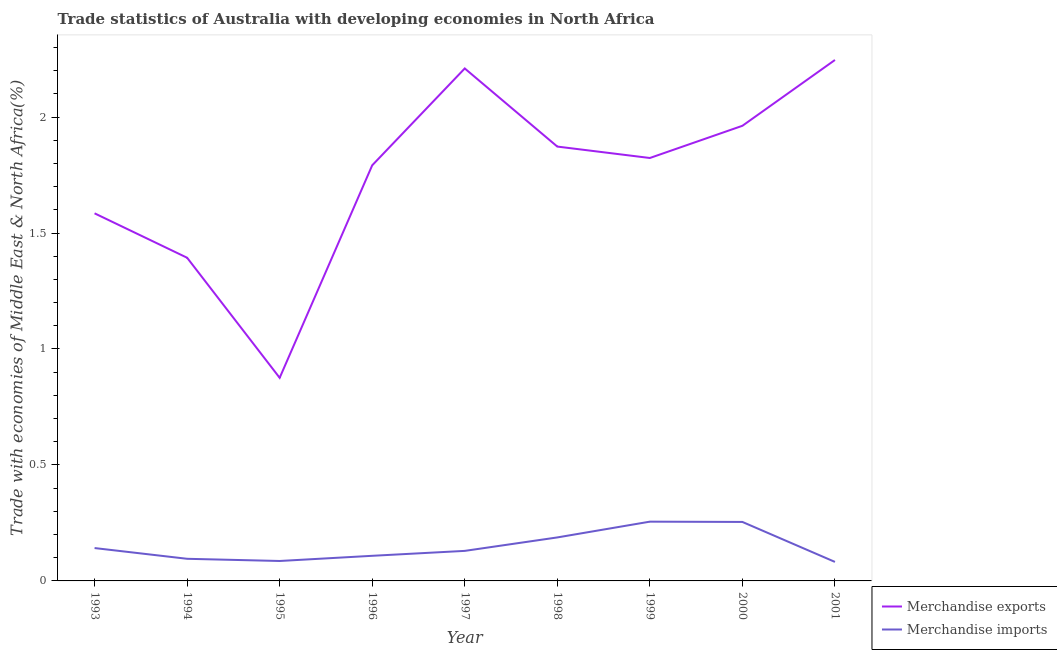How many different coloured lines are there?
Give a very brief answer. 2. Does the line corresponding to merchandise imports intersect with the line corresponding to merchandise exports?
Your answer should be compact. No. What is the merchandise exports in 1996?
Your response must be concise. 1.79. Across all years, what is the maximum merchandise exports?
Your answer should be very brief. 2.25. Across all years, what is the minimum merchandise exports?
Your response must be concise. 0.88. In which year was the merchandise exports maximum?
Your answer should be very brief. 2001. In which year was the merchandise imports minimum?
Provide a succinct answer. 2001. What is the total merchandise imports in the graph?
Give a very brief answer. 1.34. What is the difference between the merchandise exports in 1995 and that in 1996?
Provide a succinct answer. -0.92. What is the difference between the merchandise exports in 1993 and the merchandise imports in 1994?
Offer a terse response. 1.49. What is the average merchandise exports per year?
Your answer should be compact. 1.75. In the year 1996, what is the difference between the merchandise imports and merchandise exports?
Your answer should be very brief. -1.68. What is the ratio of the merchandise exports in 1997 to that in 2001?
Provide a succinct answer. 0.98. Is the difference between the merchandise imports in 1993 and 2000 greater than the difference between the merchandise exports in 1993 and 2000?
Keep it short and to the point. Yes. What is the difference between the highest and the second highest merchandise imports?
Ensure brevity in your answer.  0. What is the difference between the highest and the lowest merchandise imports?
Give a very brief answer. 0.17. In how many years, is the merchandise imports greater than the average merchandise imports taken over all years?
Your response must be concise. 3. Does the merchandise imports monotonically increase over the years?
Your response must be concise. No. Is the merchandise imports strictly less than the merchandise exports over the years?
Ensure brevity in your answer.  Yes. What is the difference between two consecutive major ticks on the Y-axis?
Offer a very short reply. 0.5. Are the values on the major ticks of Y-axis written in scientific E-notation?
Keep it short and to the point. No. Does the graph contain any zero values?
Provide a short and direct response. No. Where does the legend appear in the graph?
Give a very brief answer. Bottom right. How many legend labels are there?
Your answer should be compact. 2. How are the legend labels stacked?
Your answer should be very brief. Vertical. What is the title of the graph?
Make the answer very short. Trade statistics of Australia with developing economies in North Africa. What is the label or title of the Y-axis?
Your answer should be very brief. Trade with economies of Middle East & North Africa(%). What is the Trade with economies of Middle East & North Africa(%) of Merchandise exports in 1993?
Provide a succinct answer. 1.58. What is the Trade with economies of Middle East & North Africa(%) of Merchandise imports in 1993?
Offer a terse response. 0.14. What is the Trade with economies of Middle East & North Africa(%) of Merchandise exports in 1994?
Offer a terse response. 1.39. What is the Trade with economies of Middle East & North Africa(%) in Merchandise imports in 1994?
Offer a terse response. 0.1. What is the Trade with economies of Middle East & North Africa(%) of Merchandise exports in 1995?
Ensure brevity in your answer.  0.88. What is the Trade with economies of Middle East & North Africa(%) in Merchandise imports in 1995?
Offer a very short reply. 0.09. What is the Trade with economies of Middle East & North Africa(%) in Merchandise exports in 1996?
Your response must be concise. 1.79. What is the Trade with economies of Middle East & North Africa(%) of Merchandise imports in 1996?
Keep it short and to the point. 0.11. What is the Trade with economies of Middle East & North Africa(%) of Merchandise exports in 1997?
Offer a very short reply. 2.21. What is the Trade with economies of Middle East & North Africa(%) of Merchandise imports in 1997?
Provide a succinct answer. 0.13. What is the Trade with economies of Middle East & North Africa(%) in Merchandise exports in 1998?
Your answer should be very brief. 1.87. What is the Trade with economies of Middle East & North Africa(%) in Merchandise imports in 1998?
Keep it short and to the point. 0.19. What is the Trade with economies of Middle East & North Africa(%) in Merchandise exports in 1999?
Your answer should be compact. 1.82. What is the Trade with economies of Middle East & North Africa(%) of Merchandise imports in 1999?
Give a very brief answer. 0.26. What is the Trade with economies of Middle East & North Africa(%) of Merchandise exports in 2000?
Ensure brevity in your answer.  1.96. What is the Trade with economies of Middle East & North Africa(%) of Merchandise imports in 2000?
Your response must be concise. 0.25. What is the Trade with economies of Middle East & North Africa(%) of Merchandise exports in 2001?
Provide a short and direct response. 2.25. What is the Trade with economies of Middle East & North Africa(%) of Merchandise imports in 2001?
Your answer should be compact. 0.08. Across all years, what is the maximum Trade with economies of Middle East & North Africa(%) in Merchandise exports?
Keep it short and to the point. 2.25. Across all years, what is the maximum Trade with economies of Middle East & North Africa(%) in Merchandise imports?
Offer a terse response. 0.26. Across all years, what is the minimum Trade with economies of Middle East & North Africa(%) in Merchandise exports?
Your answer should be compact. 0.88. Across all years, what is the minimum Trade with economies of Middle East & North Africa(%) in Merchandise imports?
Your answer should be very brief. 0.08. What is the total Trade with economies of Middle East & North Africa(%) of Merchandise exports in the graph?
Offer a very short reply. 15.76. What is the total Trade with economies of Middle East & North Africa(%) in Merchandise imports in the graph?
Offer a terse response. 1.34. What is the difference between the Trade with economies of Middle East & North Africa(%) of Merchandise exports in 1993 and that in 1994?
Provide a short and direct response. 0.19. What is the difference between the Trade with economies of Middle East & North Africa(%) of Merchandise imports in 1993 and that in 1994?
Provide a succinct answer. 0.05. What is the difference between the Trade with economies of Middle East & North Africa(%) in Merchandise exports in 1993 and that in 1995?
Your response must be concise. 0.71. What is the difference between the Trade with economies of Middle East & North Africa(%) of Merchandise imports in 1993 and that in 1995?
Your answer should be compact. 0.06. What is the difference between the Trade with economies of Middle East & North Africa(%) in Merchandise exports in 1993 and that in 1996?
Provide a succinct answer. -0.21. What is the difference between the Trade with economies of Middle East & North Africa(%) of Merchandise imports in 1993 and that in 1996?
Give a very brief answer. 0.03. What is the difference between the Trade with economies of Middle East & North Africa(%) of Merchandise exports in 1993 and that in 1997?
Offer a terse response. -0.62. What is the difference between the Trade with economies of Middle East & North Africa(%) in Merchandise imports in 1993 and that in 1997?
Provide a succinct answer. 0.01. What is the difference between the Trade with economies of Middle East & North Africa(%) of Merchandise exports in 1993 and that in 1998?
Ensure brevity in your answer.  -0.29. What is the difference between the Trade with economies of Middle East & North Africa(%) of Merchandise imports in 1993 and that in 1998?
Your response must be concise. -0.05. What is the difference between the Trade with economies of Middle East & North Africa(%) of Merchandise exports in 1993 and that in 1999?
Your response must be concise. -0.24. What is the difference between the Trade with economies of Middle East & North Africa(%) in Merchandise imports in 1993 and that in 1999?
Offer a very short reply. -0.11. What is the difference between the Trade with economies of Middle East & North Africa(%) of Merchandise exports in 1993 and that in 2000?
Offer a terse response. -0.38. What is the difference between the Trade with economies of Middle East & North Africa(%) of Merchandise imports in 1993 and that in 2000?
Give a very brief answer. -0.11. What is the difference between the Trade with economies of Middle East & North Africa(%) in Merchandise exports in 1993 and that in 2001?
Make the answer very short. -0.66. What is the difference between the Trade with economies of Middle East & North Africa(%) in Merchandise imports in 1993 and that in 2001?
Ensure brevity in your answer.  0.06. What is the difference between the Trade with economies of Middle East & North Africa(%) in Merchandise exports in 1994 and that in 1995?
Keep it short and to the point. 0.52. What is the difference between the Trade with economies of Middle East & North Africa(%) in Merchandise imports in 1994 and that in 1995?
Provide a succinct answer. 0.01. What is the difference between the Trade with economies of Middle East & North Africa(%) in Merchandise exports in 1994 and that in 1996?
Offer a very short reply. -0.4. What is the difference between the Trade with economies of Middle East & North Africa(%) in Merchandise imports in 1994 and that in 1996?
Your answer should be very brief. -0.01. What is the difference between the Trade with economies of Middle East & North Africa(%) of Merchandise exports in 1994 and that in 1997?
Make the answer very short. -0.82. What is the difference between the Trade with economies of Middle East & North Africa(%) in Merchandise imports in 1994 and that in 1997?
Provide a short and direct response. -0.03. What is the difference between the Trade with economies of Middle East & North Africa(%) in Merchandise exports in 1994 and that in 1998?
Your answer should be very brief. -0.48. What is the difference between the Trade with economies of Middle East & North Africa(%) of Merchandise imports in 1994 and that in 1998?
Your answer should be compact. -0.09. What is the difference between the Trade with economies of Middle East & North Africa(%) of Merchandise exports in 1994 and that in 1999?
Your answer should be very brief. -0.43. What is the difference between the Trade with economies of Middle East & North Africa(%) of Merchandise imports in 1994 and that in 1999?
Your response must be concise. -0.16. What is the difference between the Trade with economies of Middle East & North Africa(%) in Merchandise exports in 1994 and that in 2000?
Offer a very short reply. -0.57. What is the difference between the Trade with economies of Middle East & North Africa(%) in Merchandise imports in 1994 and that in 2000?
Make the answer very short. -0.16. What is the difference between the Trade with economies of Middle East & North Africa(%) of Merchandise exports in 1994 and that in 2001?
Offer a very short reply. -0.85. What is the difference between the Trade with economies of Middle East & North Africa(%) in Merchandise imports in 1994 and that in 2001?
Offer a very short reply. 0.01. What is the difference between the Trade with economies of Middle East & North Africa(%) of Merchandise exports in 1995 and that in 1996?
Ensure brevity in your answer.  -0.92. What is the difference between the Trade with economies of Middle East & North Africa(%) of Merchandise imports in 1995 and that in 1996?
Offer a very short reply. -0.02. What is the difference between the Trade with economies of Middle East & North Africa(%) in Merchandise exports in 1995 and that in 1997?
Keep it short and to the point. -1.33. What is the difference between the Trade with economies of Middle East & North Africa(%) of Merchandise imports in 1995 and that in 1997?
Ensure brevity in your answer.  -0.04. What is the difference between the Trade with economies of Middle East & North Africa(%) in Merchandise exports in 1995 and that in 1998?
Provide a succinct answer. -1. What is the difference between the Trade with economies of Middle East & North Africa(%) of Merchandise imports in 1995 and that in 1998?
Your response must be concise. -0.1. What is the difference between the Trade with economies of Middle East & North Africa(%) in Merchandise exports in 1995 and that in 1999?
Offer a terse response. -0.95. What is the difference between the Trade with economies of Middle East & North Africa(%) in Merchandise imports in 1995 and that in 1999?
Ensure brevity in your answer.  -0.17. What is the difference between the Trade with economies of Middle East & North Africa(%) of Merchandise exports in 1995 and that in 2000?
Make the answer very short. -1.09. What is the difference between the Trade with economies of Middle East & North Africa(%) of Merchandise imports in 1995 and that in 2000?
Make the answer very short. -0.17. What is the difference between the Trade with economies of Middle East & North Africa(%) in Merchandise exports in 1995 and that in 2001?
Ensure brevity in your answer.  -1.37. What is the difference between the Trade with economies of Middle East & North Africa(%) of Merchandise imports in 1995 and that in 2001?
Provide a succinct answer. 0. What is the difference between the Trade with economies of Middle East & North Africa(%) in Merchandise exports in 1996 and that in 1997?
Your response must be concise. -0.42. What is the difference between the Trade with economies of Middle East & North Africa(%) in Merchandise imports in 1996 and that in 1997?
Ensure brevity in your answer.  -0.02. What is the difference between the Trade with economies of Middle East & North Africa(%) of Merchandise exports in 1996 and that in 1998?
Keep it short and to the point. -0.08. What is the difference between the Trade with economies of Middle East & North Africa(%) of Merchandise imports in 1996 and that in 1998?
Make the answer very short. -0.08. What is the difference between the Trade with economies of Middle East & North Africa(%) in Merchandise exports in 1996 and that in 1999?
Your answer should be compact. -0.03. What is the difference between the Trade with economies of Middle East & North Africa(%) of Merchandise imports in 1996 and that in 1999?
Offer a terse response. -0.15. What is the difference between the Trade with economies of Middle East & North Africa(%) in Merchandise exports in 1996 and that in 2000?
Keep it short and to the point. -0.17. What is the difference between the Trade with economies of Middle East & North Africa(%) of Merchandise imports in 1996 and that in 2000?
Your answer should be very brief. -0.15. What is the difference between the Trade with economies of Middle East & North Africa(%) of Merchandise exports in 1996 and that in 2001?
Offer a terse response. -0.45. What is the difference between the Trade with economies of Middle East & North Africa(%) of Merchandise imports in 1996 and that in 2001?
Provide a short and direct response. 0.03. What is the difference between the Trade with economies of Middle East & North Africa(%) of Merchandise exports in 1997 and that in 1998?
Offer a very short reply. 0.34. What is the difference between the Trade with economies of Middle East & North Africa(%) of Merchandise imports in 1997 and that in 1998?
Offer a very short reply. -0.06. What is the difference between the Trade with economies of Middle East & North Africa(%) of Merchandise exports in 1997 and that in 1999?
Keep it short and to the point. 0.39. What is the difference between the Trade with economies of Middle East & North Africa(%) in Merchandise imports in 1997 and that in 1999?
Give a very brief answer. -0.13. What is the difference between the Trade with economies of Middle East & North Africa(%) in Merchandise exports in 1997 and that in 2000?
Offer a terse response. 0.25. What is the difference between the Trade with economies of Middle East & North Africa(%) in Merchandise imports in 1997 and that in 2000?
Offer a terse response. -0.12. What is the difference between the Trade with economies of Middle East & North Africa(%) in Merchandise exports in 1997 and that in 2001?
Your answer should be compact. -0.04. What is the difference between the Trade with economies of Middle East & North Africa(%) of Merchandise imports in 1997 and that in 2001?
Provide a short and direct response. 0.05. What is the difference between the Trade with economies of Middle East & North Africa(%) of Merchandise exports in 1998 and that in 1999?
Keep it short and to the point. 0.05. What is the difference between the Trade with economies of Middle East & North Africa(%) in Merchandise imports in 1998 and that in 1999?
Your response must be concise. -0.07. What is the difference between the Trade with economies of Middle East & North Africa(%) in Merchandise exports in 1998 and that in 2000?
Provide a short and direct response. -0.09. What is the difference between the Trade with economies of Middle East & North Africa(%) in Merchandise imports in 1998 and that in 2000?
Ensure brevity in your answer.  -0.07. What is the difference between the Trade with economies of Middle East & North Africa(%) in Merchandise exports in 1998 and that in 2001?
Provide a succinct answer. -0.37. What is the difference between the Trade with economies of Middle East & North Africa(%) in Merchandise imports in 1998 and that in 2001?
Make the answer very short. 0.11. What is the difference between the Trade with economies of Middle East & North Africa(%) in Merchandise exports in 1999 and that in 2000?
Your answer should be very brief. -0.14. What is the difference between the Trade with economies of Middle East & North Africa(%) in Merchandise imports in 1999 and that in 2000?
Your answer should be very brief. 0. What is the difference between the Trade with economies of Middle East & North Africa(%) in Merchandise exports in 1999 and that in 2001?
Keep it short and to the point. -0.42. What is the difference between the Trade with economies of Middle East & North Africa(%) of Merchandise imports in 1999 and that in 2001?
Give a very brief answer. 0.17. What is the difference between the Trade with economies of Middle East & North Africa(%) of Merchandise exports in 2000 and that in 2001?
Your answer should be very brief. -0.28. What is the difference between the Trade with economies of Middle East & North Africa(%) in Merchandise imports in 2000 and that in 2001?
Give a very brief answer. 0.17. What is the difference between the Trade with economies of Middle East & North Africa(%) in Merchandise exports in 1993 and the Trade with economies of Middle East & North Africa(%) in Merchandise imports in 1994?
Provide a short and direct response. 1.49. What is the difference between the Trade with economies of Middle East & North Africa(%) of Merchandise exports in 1993 and the Trade with economies of Middle East & North Africa(%) of Merchandise imports in 1995?
Offer a terse response. 1.5. What is the difference between the Trade with economies of Middle East & North Africa(%) of Merchandise exports in 1993 and the Trade with economies of Middle East & North Africa(%) of Merchandise imports in 1996?
Your response must be concise. 1.48. What is the difference between the Trade with economies of Middle East & North Africa(%) in Merchandise exports in 1993 and the Trade with economies of Middle East & North Africa(%) in Merchandise imports in 1997?
Give a very brief answer. 1.46. What is the difference between the Trade with economies of Middle East & North Africa(%) in Merchandise exports in 1993 and the Trade with economies of Middle East & North Africa(%) in Merchandise imports in 1998?
Ensure brevity in your answer.  1.4. What is the difference between the Trade with economies of Middle East & North Africa(%) of Merchandise exports in 1993 and the Trade with economies of Middle East & North Africa(%) of Merchandise imports in 1999?
Provide a short and direct response. 1.33. What is the difference between the Trade with economies of Middle East & North Africa(%) of Merchandise exports in 1993 and the Trade with economies of Middle East & North Africa(%) of Merchandise imports in 2000?
Give a very brief answer. 1.33. What is the difference between the Trade with economies of Middle East & North Africa(%) of Merchandise exports in 1993 and the Trade with economies of Middle East & North Africa(%) of Merchandise imports in 2001?
Ensure brevity in your answer.  1.5. What is the difference between the Trade with economies of Middle East & North Africa(%) of Merchandise exports in 1994 and the Trade with economies of Middle East & North Africa(%) of Merchandise imports in 1995?
Your answer should be very brief. 1.31. What is the difference between the Trade with economies of Middle East & North Africa(%) in Merchandise exports in 1994 and the Trade with economies of Middle East & North Africa(%) in Merchandise imports in 1996?
Keep it short and to the point. 1.29. What is the difference between the Trade with economies of Middle East & North Africa(%) in Merchandise exports in 1994 and the Trade with economies of Middle East & North Africa(%) in Merchandise imports in 1997?
Your response must be concise. 1.26. What is the difference between the Trade with economies of Middle East & North Africa(%) in Merchandise exports in 1994 and the Trade with economies of Middle East & North Africa(%) in Merchandise imports in 1998?
Your response must be concise. 1.21. What is the difference between the Trade with economies of Middle East & North Africa(%) in Merchandise exports in 1994 and the Trade with economies of Middle East & North Africa(%) in Merchandise imports in 1999?
Offer a very short reply. 1.14. What is the difference between the Trade with economies of Middle East & North Africa(%) of Merchandise exports in 1994 and the Trade with economies of Middle East & North Africa(%) of Merchandise imports in 2000?
Keep it short and to the point. 1.14. What is the difference between the Trade with economies of Middle East & North Africa(%) of Merchandise exports in 1994 and the Trade with economies of Middle East & North Africa(%) of Merchandise imports in 2001?
Make the answer very short. 1.31. What is the difference between the Trade with economies of Middle East & North Africa(%) in Merchandise exports in 1995 and the Trade with economies of Middle East & North Africa(%) in Merchandise imports in 1996?
Your response must be concise. 0.77. What is the difference between the Trade with economies of Middle East & North Africa(%) of Merchandise exports in 1995 and the Trade with economies of Middle East & North Africa(%) of Merchandise imports in 1997?
Ensure brevity in your answer.  0.75. What is the difference between the Trade with economies of Middle East & North Africa(%) in Merchandise exports in 1995 and the Trade with economies of Middle East & North Africa(%) in Merchandise imports in 1998?
Offer a terse response. 0.69. What is the difference between the Trade with economies of Middle East & North Africa(%) in Merchandise exports in 1995 and the Trade with economies of Middle East & North Africa(%) in Merchandise imports in 1999?
Ensure brevity in your answer.  0.62. What is the difference between the Trade with economies of Middle East & North Africa(%) in Merchandise exports in 1995 and the Trade with economies of Middle East & North Africa(%) in Merchandise imports in 2000?
Offer a terse response. 0.62. What is the difference between the Trade with economies of Middle East & North Africa(%) in Merchandise exports in 1995 and the Trade with economies of Middle East & North Africa(%) in Merchandise imports in 2001?
Ensure brevity in your answer.  0.79. What is the difference between the Trade with economies of Middle East & North Africa(%) of Merchandise exports in 1996 and the Trade with economies of Middle East & North Africa(%) of Merchandise imports in 1997?
Provide a short and direct response. 1.66. What is the difference between the Trade with economies of Middle East & North Africa(%) of Merchandise exports in 1996 and the Trade with economies of Middle East & North Africa(%) of Merchandise imports in 1998?
Ensure brevity in your answer.  1.6. What is the difference between the Trade with economies of Middle East & North Africa(%) in Merchandise exports in 1996 and the Trade with economies of Middle East & North Africa(%) in Merchandise imports in 1999?
Your response must be concise. 1.54. What is the difference between the Trade with economies of Middle East & North Africa(%) in Merchandise exports in 1996 and the Trade with economies of Middle East & North Africa(%) in Merchandise imports in 2000?
Your answer should be compact. 1.54. What is the difference between the Trade with economies of Middle East & North Africa(%) of Merchandise exports in 1996 and the Trade with economies of Middle East & North Africa(%) of Merchandise imports in 2001?
Ensure brevity in your answer.  1.71. What is the difference between the Trade with economies of Middle East & North Africa(%) in Merchandise exports in 1997 and the Trade with economies of Middle East & North Africa(%) in Merchandise imports in 1998?
Offer a terse response. 2.02. What is the difference between the Trade with economies of Middle East & North Africa(%) of Merchandise exports in 1997 and the Trade with economies of Middle East & North Africa(%) of Merchandise imports in 1999?
Provide a short and direct response. 1.95. What is the difference between the Trade with economies of Middle East & North Africa(%) in Merchandise exports in 1997 and the Trade with economies of Middle East & North Africa(%) in Merchandise imports in 2000?
Ensure brevity in your answer.  1.96. What is the difference between the Trade with economies of Middle East & North Africa(%) of Merchandise exports in 1997 and the Trade with economies of Middle East & North Africa(%) of Merchandise imports in 2001?
Offer a terse response. 2.13. What is the difference between the Trade with economies of Middle East & North Africa(%) of Merchandise exports in 1998 and the Trade with economies of Middle East & North Africa(%) of Merchandise imports in 1999?
Provide a short and direct response. 1.62. What is the difference between the Trade with economies of Middle East & North Africa(%) in Merchandise exports in 1998 and the Trade with economies of Middle East & North Africa(%) in Merchandise imports in 2000?
Your answer should be very brief. 1.62. What is the difference between the Trade with economies of Middle East & North Africa(%) of Merchandise exports in 1998 and the Trade with economies of Middle East & North Africa(%) of Merchandise imports in 2001?
Your response must be concise. 1.79. What is the difference between the Trade with economies of Middle East & North Africa(%) of Merchandise exports in 1999 and the Trade with economies of Middle East & North Africa(%) of Merchandise imports in 2000?
Your answer should be very brief. 1.57. What is the difference between the Trade with economies of Middle East & North Africa(%) in Merchandise exports in 1999 and the Trade with economies of Middle East & North Africa(%) in Merchandise imports in 2001?
Provide a short and direct response. 1.74. What is the difference between the Trade with economies of Middle East & North Africa(%) of Merchandise exports in 2000 and the Trade with economies of Middle East & North Africa(%) of Merchandise imports in 2001?
Your answer should be very brief. 1.88. What is the average Trade with economies of Middle East & North Africa(%) in Merchandise exports per year?
Make the answer very short. 1.75. What is the average Trade with economies of Middle East & North Africa(%) of Merchandise imports per year?
Provide a succinct answer. 0.15. In the year 1993, what is the difference between the Trade with economies of Middle East & North Africa(%) in Merchandise exports and Trade with economies of Middle East & North Africa(%) in Merchandise imports?
Your response must be concise. 1.44. In the year 1994, what is the difference between the Trade with economies of Middle East & North Africa(%) of Merchandise exports and Trade with economies of Middle East & North Africa(%) of Merchandise imports?
Provide a short and direct response. 1.3. In the year 1995, what is the difference between the Trade with economies of Middle East & North Africa(%) of Merchandise exports and Trade with economies of Middle East & North Africa(%) of Merchandise imports?
Make the answer very short. 0.79. In the year 1996, what is the difference between the Trade with economies of Middle East & North Africa(%) of Merchandise exports and Trade with economies of Middle East & North Africa(%) of Merchandise imports?
Keep it short and to the point. 1.68. In the year 1997, what is the difference between the Trade with economies of Middle East & North Africa(%) of Merchandise exports and Trade with economies of Middle East & North Africa(%) of Merchandise imports?
Ensure brevity in your answer.  2.08. In the year 1998, what is the difference between the Trade with economies of Middle East & North Africa(%) of Merchandise exports and Trade with economies of Middle East & North Africa(%) of Merchandise imports?
Your answer should be very brief. 1.69. In the year 1999, what is the difference between the Trade with economies of Middle East & North Africa(%) in Merchandise exports and Trade with economies of Middle East & North Africa(%) in Merchandise imports?
Provide a succinct answer. 1.57. In the year 2000, what is the difference between the Trade with economies of Middle East & North Africa(%) of Merchandise exports and Trade with economies of Middle East & North Africa(%) of Merchandise imports?
Your response must be concise. 1.71. In the year 2001, what is the difference between the Trade with economies of Middle East & North Africa(%) of Merchandise exports and Trade with economies of Middle East & North Africa(%) of Merchandise imports?
Keep it short and to the point. 2.16. What is the ratio of the Trade with economies of Middle East & North Africa(%) in Merchandise exports in 1993 to that in 1994?
Provide a short and direct response. 1.14. What is the ratio of the Trade with economies of Middle East & North Africa(%) of Merchandise imports in 1993 to that in 1994?
Your answer should be very brief. 1.49. What is the ratio of the Trade with economies of Middle East & North Africa(%) of Merchandise exports in 1993 to that in 1995?
Provide a short and direct response. 1.81. What is the ratio of the Trade with economies of Middle East & North Africa(%) of Merchandise imports in 1993 to that in 1995?
Offer a very short reply. 1.65. What is the ratio of the Trade with economies of Middle East & North Africa(%) in Merchandise exports in 1993 to that in 1996?
Offer a terse response. 0.88. What is the ratio of the Trade with economies of Middle East & North Africa(%) in Merchandise imports in 1993 to that in 1996?
Your response must be concise. 1.31. What is the ratio of the Trade with economies of Middle East & North Africa(%) in Merchandise exports in 1993 to that in 1997?
Keep it short and to the point. 0.72. What is the ratio of the Trade with economies of Middle East & North Africa(%) in Merchandise imports in 1993 to that in 1997?
Your response must be concise. 1.09. What is the ratio of the Trade with economies of Middle East & North Africa(%) in Merchandise exports in 1993 to that in 1998?
Your answer should be compact. 0.85. What is the ratio of the Trade with economies of Middle East & North Africa(%) in Merchandise imports in 1993 to that in 1998?
Provide a succinct answer. 0.76. What is the ratio of the Trade with economies of Middle East & North Africa(%) in Merchandise exports in 1993 to that in 1999?
Provide a succinct answer. 0.87. What is the ratio of the Trade with economies of Middle East & North Africa(%) of Merchandise imports in 1993 to that in 1999?
Ensure brevity in your answer.  0.55. What is the ratio of the Trade with economies of Middle East & North Africa(%) of Merchandise exports in 1993 to that in 2000?
Ensure brevity in your answer.  0.81. What is the ratio of the Trade with economies of Middle East & North Africa(%) in Merchandise imports in 1993 to that in 2000?
Provide a short and direct response. 0.56. What is the ratio of the Trade with economies of Middle East & North Africa(%) in Merchandise exports in 1993 to that in 2001?
Provide a short and direct response. 0.71. What is the ratio of the Trade with economies of Middle East & North Africa(%) in Merchandise imports in 1993 to that in 2001?
Ensure brevity in your answer.  1.73. What is the ratio of the Trade with economies of Middle East & North Africa(%) in Merchandise exports in 1994 to that in 1995?
Ensure brevity in your answer.  1.59. What is the ratio of the Trade with economies of Middle East & North Africa(%) of Merchandise imports in 1994 to that in 1995?
Your answer should be very brief. 1.11. What is the ratio of the Trade with economies of Middle East & North Africa(%) of Merchandise exports in 1994 to that in 1996?
Provide a short and direct response. 0.78. What is the ratio of the Trade with economies of Middle East & North Africa(%) of Merchandise imports in 1994 to that in 1996?
Keep it short and to the point. 0.88. What is the ratio of the Trade with economies of Middle East & North Africa(%) of Merchandise exports in 1994 to that in 1997?
Your answer should be very brief. 0.63. What is the ratio of the Trade with economies of Middle East & North Africa(%) in Merchandise imports in 1994 to that in 1997?
Offer a very short reply. 0.74. What is the ratio of the Trade with economies of Middle East & North Africa(%) in Merchandise exports in 1994 to that in 1998?
Keep it short and to the point. 0.74. What is the ratio of the Trade with economies of Middle East & North Africa(%) of Merchandise imports in 1994 to that in 1998?
Give a very brief answer. 0.51. What is the ratio of the Trade with economies of Middle East & North Africa(%) of Merchandise exports in 1994 to that in 1999?
Provide a short and direct response. 0.76. What is the ratio of the Trade with economies of Middle East & North Africa(%) of Merchandise imports in 1994 to that in 1999?
Offer a terse response. 0.37. What is the ratio of the Trade with economies of Middle East & North Africa(%) of Merchandise exports in 1994 to that in 2000?
Make the answer very short. 0.71. What is the ratio of the Trade with economies of Middle East & North Africa(%) of Merchandise imports in 1994 to that in 2000?
Provide a succinct answer. 0.38. What is the ratio of the Trade with economies of Middle East & North Africa(%) of Merchandise exports in 1994 to that in 2001?
Your answer should be very brief. 0.62. What is the ratio of the Trade with economies of Middle East & North Africa(%) in Merchandise imports in 1994 to that in 2001?
Keep it short and to the point. 1.16. What is the ratio of the Trade with economies of Middle East & North Africa(%) in Merchandise exports in 1995 to that in 1996?
Offer a terse response. 0.49. What is the ratio of the Trade with economies of Middle East & North Africa(%) of Merchandise imports in 1995 to that in 1996?
Provide a short and direct response. 0.79. What is the ratio of the Trade with economies of Middle East & North Africa(%) of Merchandise exports in 1995 to that in 1997?
Offer a terse response. 0.4. What is the ratio of the Trade with economies of Middle East & North Africa(%) of Merchandise imports in 1995 to that in 1997?
Offer a very short reply. 0.66. What is the ratio of the Trade with economies of Middle East & North Africa(%) in Merchandise exports in 1995 to that in 1998?
Keep it short and to the point. 0.47. What is the ratio of the Trade with economies of Middle East & North Africa(%) of Merchandise imports in 1995 to that in 1998?
Your response must be concise. 0.46. What is the ratio of the Trade with economies of Middle East & North Africa(%) of Merchandise exports in 1995 to that in 1999?
Your response must be concise. 0.48. What is the ratio of the Trade with economies of Middle East & North Africa(%) of Merchandise imports in 1995 to that in 1999?
Offer a very short reply. 0.34. What is the ratio of the Trade with economies of Middle East & North Africa(%) in Merchandise exports in 1995 to that in 2000?
Your answer should be compact. 0.45. What is the ratio of the Trade with economies of Middle East & North Africa(%) in Merchandise imports in 1995 to that in 2000?
Provide a succinct answer. 0.34. What is the ratio of the Trade with economies of Middle East & North Africa(%) of Merchandise exports in 1995 to that in 2001?
Make the answer very short. 0.39. What is the ratio of the Trade with economies of Middle East & North Africa(%) in Merchandise imports in 1995 to that in 2001?
Provide a short and direct response. 1.05. What is the ratio of the Trade with economies of Middle East & North Africa(%) of Merchandise exports in 1996 to that in 1997?
Your answer should be compact. 0.81. What is the ratio of the Trade with economies of Middle East & North Africa(%) of Merchandise imports in 1996 to that in 1997?
Make the answer very short. 0.84. What is the ratio of the Trade with economies of Middle East & North Africa(%) in Merchandise exports in 1996 to that in 1998?
Provide a succinct answer. 0.96. What is the ratio of the Trade with economies of Middle East & North Africa(%) of Merchandise imports in 1996 to that in 1998?
Provide a short and direct response. 0.58. What is the ratio of the Trade with economies of Middle East & North Africa(%) of Merchandise exports in 1996 to that in 1999?
Ensure brevity in your answer.  0.98. What is the ratio of the Trade with economies of Middle East & North Africa(%) in Merchandise imports in 1996 to that in 1999?
Offer a very short reply. 0.42. What is the ratio of the Trade with economies of Middle East & North Africa(%) in Merchandise exports in 1996 to that in 2000?
Offer a very short reply. 0.91. What is the ratio of the Trade with economies of Middle East & North Africa(%) of Merchandise imports in 1996 to that in 2000?
Offer a terse response. 0.43. What is the ratio of the Trade with economies of Middle East & North Africa(%) in Merchandise exports in 1996 to that in 2001?
Offer a terse response. 0.8. What is the ratio of the Trade with economies of Middle East & North Africa(%) in Merchandise imports in 1996 to that in 2001?
Ensure brevity in your answer.  1.32. What is the ratio of the Trade with economies of Middle East & North Africa(%) of Merchandise exports in 1997 to that in 1998?
Your answer should be very brief. 1.18. What is the ratio of the Trade with economies of Middle East & North Africa(%) in Merchandise imports in 1997 to that in 1998?
Offer a very short reply. 0.69. What is the ratio of the Trade with economies of Middle East & North Africa(%) of Merchandise exports in 1997 to that in 1999?
Give a very brief answer. 1.21. What is the ratio of the Trade with economies of Middle East & North Africa(%) in Merchandise imports in 1997 to that in 1999?
Provide a short and direct response. 0.51. What is the ratio of the Trade with economies of Middle East & North Africa(%) in Merchandise exports in 1997 to that in 2000?
Offer a terse response. 1.13. What is the ratio of the Trade with economies of Middle East & North Africa(%) of Merchandise imports in 1997 to that in 2000?
Make the answer very short. 0.51. What is the ratio of the Trade with economies of Middle East & North Africa(%) in Merchandise exports in 1997 to that in 2001?
Give a very brief answer. 0.98. What is the ratio of the Trade with economies of Middle East & North Africa(%) in Merchandise imports in 1997 to that in 2001?
Your response must be concise. 1.58. What is the ratio of the Trade with economies of Middle East & North Africa(%) of Merchandise exports in 1998 to that in 1999?
Offer a terse response. 1.03. What is the ratio of the Trade with economies of Middle East & North Africa(%) in Merchandise imports in 1998 to that in 1999?
Ensure brevity in your answer.  0.73. What is the ratio of the Trade with economies of Middle East & North Africa(%) of Merchandise exports in 1998 to that in 2000?
Ensure brevity in your answer.  0.95. What is the ratio of the Trade with economies of Middle East & North Africa(%) in Merchandise imports in 1998 to that in 2000?
Offer a very short reply. 0.74. What is the ratio of the Trade with economies of Middle East & North Africa(%) in Merchandise exports in 1998 to that in 2001?
Keep it short and to the point. 0.83. What is the ratio of the Trade with economies of Middle East & North Africa(%) in Merchandise imports in 1998 to that in 2001?
Ensure brevity in your answer.  2.29. What is the ratio of the Trade with economies of Middle East & North Africa(%) of Merchandise exports in 1999 to that in 2000?
Give a very brief answer. 0.93. What is the ratio of the Trade with economies of Middle East & North Africa(%) in Merchandise imports in 1999 to that in 2000?
Provide a short and direct response. 1. What is the ratio of the Trade with economies of Middle East & North Africa(%) of Merchandise exports in 1999 to that in 2001?
Give a very brief answer. 0.81. What is the ratio of the Trade with economies of Middle East & North Africa(%) in Merchandise imports in 1999 to that in 2001?
Your answer should be compact. 3.12. What is the ratio of the Trade with economies of Middle East & North Africa(%) of Merchandise exports in 2000 to that in 2001?
Offer a terse response. 0.87. What is the ratio of the Trade with economies of Middle East & North Africa(%) in Merchandise imports in 2000 to that in 2001?
Offer a terse response. 3.1. What is the difference between the highest and the second highest Trade with economies of Middle East & North Africa(%) in Merchandise exports?
Keep it short and to the point. 0.04. What is the difference between the highest and the second highest Trade with economies of Middle East & North Africa(%) of Merchandise imports?
Ensure brevity in your answer.  0. What is the difference between the highest and the lowest Trade with economies of Middle East & North Africa(%) in Merchandise exports?
Provide a succinct answer. 1.37. What is the difference between the highest and the lowest Trade with economies of Middle East & North Africa(%) of Merchandise imports?
Provide a short and direct response. 0.17. 